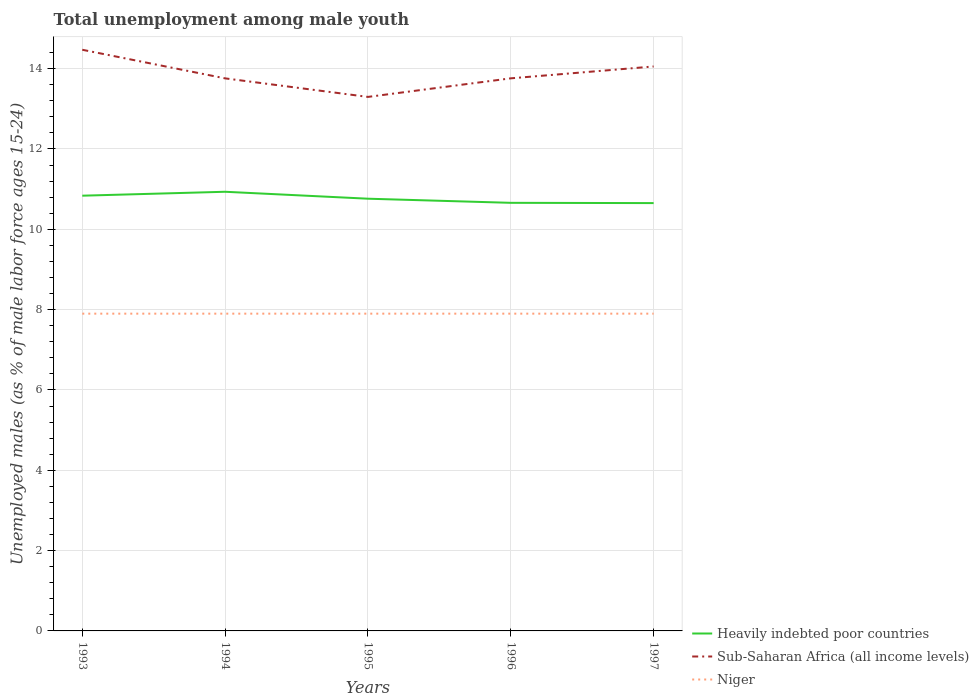How many different coloured lines are there?
Offer a very short reply. 3. Is the number of lines equal to the number of legend labels?
Make the answer very short. Yes. Across all years, what is the maximum percentage of unemployed males in in Niger?
Give a very brief answer. 7.9. What is the total percentage of unemployed males in in Heavily indebted poor countries in the graph?
Make the answer very short. 0.28. What is the difference between the highest and the second highest percentage of unemployed males in in Heavily indebted poor countries?
Ensure brevity in your answer.  0.28. What is the difference between the highest and the lowest percentage of unemployed males in in Sub-Saharan Africa (all income levels)?
Provide a short and direct response. 2. How many lines are there?
Ensure brevity in your answer.  3. How many years are there in the graph?
Your response must be concise. 5. Are the values on the major ticks of Y-axis written in scientific E-notation?
Give a very brief answer. No. Does the graph contain grids?
Provide a succinct answer. Yes. Where does the legend appear in the graph?
Give a very brief answer. Bottom right. How many legend labels are there?
Provide a succinct answer. 3. How are the legend labels stacked?
Your response must be concise. Vertical. What is the title of the graph?
Offer a very short reply. Total unemployment among male youth. Does "Barbados" appear as one of the legend labels in the graph?
Your answer should be compact. No. What is the label or title of the Y-axis?
Give a very brief answer. Unemployed males (as % of male labor force ages 15-24). What is the Unemployed males (as % of male labor force ages 15-24) of Heavily indebted poor countries in 1993?
Give a very brief answer. 10.84. What is the Unemployed males (as % of male labor force ages 15-24) of Sub-Saharan Africa (all income levels) in 1993?
Give a very brief answer. 14.47. What is the Unemployed males (as % of male labor force ages 15-24) in Niger in 1993?
Your answer should be compact. 7.9. What is the Unemployed males (as % of male labor force ages 15-24) in Heavily indebted poor countries in 1994?
Provide a succinct answer. 10.94. What is the Unemployed males (as % of male labor force ages 15-24) in Sub-Saharan Africa (all income levels) in 1994?
Provide a succinct answer. 13.76. What is the Unemployed males (as % of male labor force ages 15-24) in Niger in 1994?
Give a very brief answer. 7.9. What is the Unemployed males (as % of male labor force ages 15-24) of Heavily indebted poor countries in 1995?
Offer a very short reply. 10.76. What is the Unemployed males (as % of male labor force ages 15-24) in Sub-Saharan Africa (all income levels) in 1995?
Keep it short and to the point. 13.3. What is the Unemployed males (as % of male labor force ages 15-24) in Niger in 1995?
Ensure brevity in your answer.  7.9. What is the Unemployed males (as % of male labor force ages 15-24) of Heavily indebted poor countries in 1996?
Your answer should be very brief. 10.66. What is the Unemployed males (as % of male labor force ages 15-24) in Sub-Saharan Africa (all income levels) in 1996?
Your answer should be very brief. 13.76. What is the Unemployed males (as % of male labor force ages 15-24) of Niger in 1996?
Keep it short and to the point. 7.9. What is the Unemployed males (as % of male labor force ages 15-24) in Heavily indebted poor countries in 1997?
Offer a very short reply. 10.65. What is the Unemployed males (as % of male labor force ages 15-24) in Sub-Saharan Africa (all income levels) in 1997?
Your response must be concise. 14.06. What is the Unemployed males (as % of male labor force ages 15-24) of Niger in 1997?
Keep it short and to the point. 7.9. Across all years, what is the maximum Unemployed males (as % of male labor force ages 15-24) of Heavily indebted poor countries?
Make the answer very short. 10.94. Across all years, what is the maximum Unemployed males (as % of male labor force ages 15-24) of Sub-Saharan Africa (all income levels)?
Ensure brevity in your answer.  14.47. Across all years, what is the maximum Unemployed males (as % of male labor force ages 15-24) of Niger?
Your answer should be compact. 7.9. Across all years, what is the minimum Unemployed males (as % of male labor force ages 15-24) of Heavily indebted poor countries?
Ensure brevity in your answer.  10.65. Across all years, what is the minimum Unemployed males (as % of male labor force ages 15-24) in Sub-Saharan Africa (all income levels)?
Keep it short and to the point. 13.3. Across all years, what is the minimum Unemployed males (as % of male labor force ages 15-24) of Niger?
Offer a terse response. 7.9. What is the total Unemployed males (as % of male labor force ages 15-24) in Heavily indebted poor countries in the graph?
Provide a short and direct response. 53.85. What is the total Unemployed males (as % of male labor force ages 15-24) of Sub-Saharan Africa (all income levels) in the graph?
Offer a very short reply. 69.34. What is the total Unemployed males (as % of male labor force ages 15-24) of Niger in the graph?
Your answer should be compact. 39.5. What is the difference between the Unemployed males (as % of male labor force ages 15-24) in Heavily indebted poor countries in 1993 and that in 1994?
Offer a very short reply. -0.1. What is the difference between the Unemployed males (as % of male labor force ages 15-24) in Sub-Saharan Africa (all income levels) in 1993 and that in 1994?
Ensure brevity in your answer.  0.71. What is the difference between the Unemployed males (as % of male labor force ages 15-24) in Heavily indebted poor countries in 1993 and that in 1995?
Your response must be concise. 0.07. What is the difference between the Unemployed males (as % of male labor force ages 15-24) in Sub-Saharan Africa (all income levels) in 1993 and that in 1995?
Offer a terse response. 1.17. What is the difference between the Unemployed males (as % of male labor force ages 15-24) of Heavily indebted poor countries in 1993 and that in 1996?
Offer a terse response. 0.18. What is the difference between the Unemployed males (as % of male labor force ages 15-24) of Sub-Saharan Africa (all income levels) in 1993 and that in 1996?
Make the answer very short. 0.71. What is the difference between the Unemployed males (as % of male labor force ages 15-24) of Heavily indebted poor countries in 1993 and that in 1997?
Your answer should be very brief. 0.18. What is the difference between the Unemployed males (as % of male labor force ages 15-24) in Sub-Saharan Africa (all income levels) in 1993 and that in 1997?
Your answer should be very brief. 0.42. What is the difference between the Unemployed males (as % of male labor force ages 15-24) in Niger in 1993 and that in 1997?
Ensure brevity in your answer.  0. What is the difference between the Unemployed males (as % of male labor force ages 15-24) of Heavily indebted poor countries in 1994 and that in 1995?
Your answer should be very brief. 0.17. What is the difference between the Unemployed males (as % of male labor force ages 15-24) of Sub-Saharan Africa (all income levels) in 1994 and that in 1995?
Your response must be concise. 0.46. What is the difference between the Unemployed males (as % of male labor force ages 15-24) in Niger in 1994 and that in 1995?
Your answer should be compact. 0. What is the difference between the Unemployed males (as % of male labor force ages 15-24) of Heavily indebted poor countries in 1994 and that in 1996?
Offer a terse response. 0.28. What is the difference between the Unemployed males (as % of male labor force ages 15-24) of Sub-Saharan Africa (all income levels) in 1994 and that in 1996?
Offer a very short reply. -0. What is the difference between the Unemployed males (as % of male labor force ages 15-24) of Niger in 1994 and that in 1996?
Provide a succinct answer. 0. What is the difference between the Unemployed males (as % of male labor force ages 15-24) of Heavily indebted poor countries in 1994 and that in 1997?
Ensure brevity in your answer.  0.28. What is the difference between the Unemployed males (as % of male labor force ages 15-24) of Sub-Saharan Africa (all income levels) in 1994 and that in 1997?
Your response must be concise. -0.3. What is the difference between the Unemployed males (as % of male labor force ages 15-24) of Heavily indebted poor countries in 1995 and that in 1996?
Keep it short and to the point. 0.1. What is the difference between the Unemployed males (as % of male labor force ages 15-24) of Sub-Saharan Africa (all income levels) in 1995 and that in 1996?
Your answer should be very brief. -0.46. What is the difference between the Unemployed males (as % of male labor force ages 15-24) of Niger in 1995 and that in 1996?
Ensure brevity in your answer.  0. What is the difference between the Unemployed males (as % of male labor force ages 15-24) of Heavily indebted poor countries in 1995 and that in 1997?
Offer a terse response. 0.11. What is the difference between the Unemployed males (as % of male labor force ages 15-24) of Sub-Saharan Africa (all income levels) in 1995 and that in 1997?
Keep it short and to the point. -0.76. What is the difference between the Unemployed males (as % of male labor force ages 15-24) of Niger in 1995 and that in 1997?
Provide a succinct answer. 0. What is the difference between the Unemployed males (as % of male labor force ages 15-24) in Heavily indebted poor countries in 1996 and that in 1997?
Make the answer very short. 0.01. What is the difference between the Unemployed males (as % of male labor force ages 15-24) in Sub-Saharan Africa (all income levels) in 1996 and that in 1997?
Provide a short and direct response. -0.3. What is the difference between the Unemployed males (as % of male labor force ages 15-24) of Niger in 1996 and that in 1997?
Ensure brevity in your answer.  0. What is the difference between the Unemployed males (as % of male labor force ages 15-24) in Heavily indebted poor countries in 1993 and the Unemployed males (as % of male labor force ages 15-24) in Sub-Saharan Africa (all income levels) in 1994?
Give a very brief answer. -2.92. What is the difference between the Unemployed males (as % of male labor force ages 15-24) of Heavily indebted poor countries in 1993 and the Unemployed males (as % of male labor force ages 15-24) of Niger in 1994?
Offer a terse response. 2.94. What is the difference between the Unemployed males (as % of male labor force ages 15-24) of Sub-Saharan Africa (all income levels) in 1993 and the Unemployed males (as % of male labor force ages 15-24) of Niger in 1994?
Provide a short and direct response. 6.57. What is the difference between the Unemployed males (as % of male labor force ages 15-24) in Heavily indebted poor countries in 1993 and the Unemployed males (as % of male labor force ages 15-24) in Sub-Saharan Africa (all income levels) in 1995?
Your response must be concise. -2.46. What is the difference between the Unemployed males (as % of male labor force ages 15-24) in Heavily indebted poor countries in 1993 and the Unemployed males (as % of male labor force ages 15-24) in Niger in 1995?
Keep it short and to the point. 2.94. What is the difference between the Unemployed males (as % of male labor force ages 15-24) in Sub-Saharan Africa (all income levels) in 1993 and the Unemployed males (as % of male labor force ages 15-24) in Niger in 1995?
Provide a succinct answer. 6.57. What is the difference between the Unemployed males (as % of male labor force ages 15-24) of Heavily indebted poor countries in 1993 and the Unemployed males (as % of male labor force ages 15-24) of Sub-Saharan Africa (all income levels) in 1996?
Ensure brevity in your answer.  -2.92. What is the difference between the Unemployed males (as % of male labor force ages 15-24) of Heavily indebted poor countries in 1993 and the Unemployed males (as % of male labor force ages 15-24) of Niger in 1996?
Ensure brevity in your answer.  2.94. What is the difference between the Unemployed males (as % of male labor force ages 15-24) in Sub-Saharan Africa (all income levels) in 1993 and the Unemployed males (as % of male labor force ages 15-24) in Niger in 1996?
Keep it short and to the point. 6.57. What is the difference between the Unemployed males (as % of male labor force ages 15-24) in Heavily indebted poor countries in 1993 and the Unemployed males (as % of male labor force ages 15-24) in Sub-Saharan Africa (all income levels) in 1997?
Offer a terse response. -3.22. What is the difference between the Unemployed males (as % of male labor force ages 15-24) of Heavily indebted poor countries in 1993 and the Unemployed males (as % of male labor force ages 15-24) of Niger in 1997?
Your answer should be very brief. 2.94. What is the difference between the Unemployed males (as % of male labor force ages 15-24) of Sub-Saharan Africa (all income levels) in 1993 and the Unemployed males (as % of male labor force ages 15-24) of Niger in 1997?
Provide a succinct answer. 6.57. What is the difference between the Unemployed males (as % of male labor force ages 15-24) of Heavily indebted poor countries in 1994 and the Unemployed males (as % of male labor force ages 15-24) of Sub-Saharan Africa (all income levels) in 1995?
Your answer should be very brief. -2.36. What is the difference between the Unemployed males (as % of male labor force ages 15-24) in Heavily indebted poor countries in 1994 and the Unemployed males (as % of male labor force ages 15-24) in Niger in 1995?
Provide a short and direct response. 3.04. What is the difference between the Unemployed males (as % of male labor force ages 15-24) of Sub-Saharan Africa (all income levels) in 1994 and the Unemployed males (as % of male labor force ages 15-24) of Niger in 1995?
Offer a very short reply. 5.86. What is the difference between the Unemployed males (as % of male labor force ages 15-24) of Heavily indebted poor countries in 1994 and the Unemployed males (as % of male labor force ages 15-24) of Sub-Saharan Africa (all income levels) in 1996?
Offer a very short reply. -2.82. What is the difference between the Unemployed males (as % of male labor force ages 15-24) in Heavily indebted poor countries in 1994 and the Unemployed males (as % of male labor force ages 15-24) in Niger in 1996?
Make the answer very short. 3.04. What is the difference between the Unemployed males (as % of male labor force ages 15-24) in Sub-Saharan Africa (all income levels) in 1994 and the Unemployed males (as % of male labor force ages 15-24) in Niger in 1996?
Make the answer very short. 5.86. What is the difference between the Unemployed males (as % of male labor force ages 15-24) in Heavily indebted poor countries in 1994 and the Unemployed males (as % of male labor force ages 15-24) in Sub-Saharan Africa (all income levels) in 1997?
Keep it short and to the point. -3.12. What is the difference between the Unemployed males (as % of male labor force ages 15-24) in Heavily indebted poor countries in 1994 and the Unemployed males (as % of male labor force ages 15-24) in Niger in 1997?
Offer a terse response. 3.04. What is the difference between the Unemployed males (as % of male labor force ages 15-24) in Sub-Saharan Africa (all income levels) in 1994 and the Unemployed males (as % of male labor force ages 15-24) in Niger in 1997?
Give a very brief answer. 5.86. What is the difference between the Unemployed males (as % of male labor force ages 15-24) in Heavily indebted poor countries in 1995 and the Unemployed males (as % of male labor force ages 15-24) in Sub-Saharan Africa (all income levels) in 1996?
Your answer should be compact. -3. What is the difference between the Unemployed males (as % of male labor force ages 15-24) in Heavily indebted poor countries in 1995 and the Unemployed males (as % of male labor force ages 15-24) in Niger in 1996?
Provide a short and direct response. 2.86. What is the difference between the Unemployed males (as % of male labor force ages 15-24) of Sub-Saharan Africa (all income levels) in 1995 and the Unemployed males (as % of male labor force ages 15-24) of Niger in 1996?
Your answer should be compact. 5.4. What is the difference between the Unemployed males (as % of male labor force ages 15-24) in Heavily indebted poor countries in 1995 and the Unemployed males (as % of male labor force ages 15-24) in Sub-Saharan Africa (all income levels) in 1997?
Give a very brief answer. -3.29. What is the difference between the Unemployed males (as % of male labor force ages 15-24) of Heavily indebted poor countries in 1995 and the Unemployed males (as % of male labor force ages 15-24) of Niger in 1997?
Offer a very short reply. 2.86. What is the difference between the Unemployed males (as % of male labor force ages 15-24) in Sub-Saharan Africa (all income levels) in 1995 and the Unemployed males (as % of male labor force ages 15-24) in Niger in 1997?
Provide a short and direct response. 5.4. What is the difference between the Unemployed males (as % of male labor force ages 15-24) in Heavily indebted poor countries in 1996 and the Unemployed males (as % of male labor force ages 15-24) in Sub-Saharan Africa (all income levels) in 1997?
Keep it short and to the point. -3.4. What is the difference between the Unemployed males (as % of male labor force ages 15-24) of Heavily indebted poor countries in 1996 and the Unemployed males (as % of male labor force ages 15-24) of Niger in 1997?
Provide a succinct answer. 2.76. What is the difference between the Unemployed males (as % of male labor force ages 15-24) of Sub-Saharan Africa (all income levels) in 1996 and the Unemployed males (as % of male labor force ages 15-24) of Niger in 1997?
Your answer should be compact. 5.86. What is the average Unemployed males (as % of male labor force ages 15-24) in Heavily indebted poor countries per year?
Keep it short and to the point. 10.77. What is the average Unemployed males (as % of male labor force ages 15-24) in Sub-Saharan Africa (all income levels) per year?
Offer a very short reply. 13.87. In the year 1993, what is the difference between the Unemployed males (as % of male labor force ages 15-24) in Heavily indebted poor countries and Unemployed males (as % of male labor force ages 15-24) in Sub-Saharan Africa (all income levels)?
Give a very brief answer. -3.63. In the year 1993, what is the difference between the Unemployed males (as % of male labor force ages 15-24) of Heavily indebted poor countries and Unemployed males (as % of male labor force ages 15-24) of Niger?
Your response must be concise. 2.94. In the year 1993, what is the difference between the Unemployed males (as % of male labor force ages 15-24) in Sub-Saharan Africa (all income levels) and Unemployed males (as % of male labor force ages 15-24) in Niger?
Your answer should be very brief. 6.57. In the year 1994, what is the difference between the Unemployed males (as % of male labor force ages 15-24) in Heavily indebted poor countries and Unemployed males (as % of male labor force ages 15-24) in Sub-Saharan Africa (all income levels)?
Keep it short and to the point. -2.82. In the year 1994, what is the difference between the Unemployed males (as % of male labor force ages 15-24) of Heavily indebted poor countries and Unemployed males (as % of male labor force ages 15-24) of Niger?
Your answer should be compact. 3.04. In the year 1994, what is the difference between the Unemployed males (as % of male labor force ages 15-24) of Sub-Saharan Africa (all income levels) and Unemployed males (as % of male labor force ages 15-24) of Niger?
Provide a short and direct response. 5.86. In the year 1995, what is the difference between the Unemployed males (as % of male labor force ages 15-24) in Heavily indebted poor countries and Unemployed males (as % of male labor force ages 15-24) in Sub-Saharan Africa (all income levels)?
Your response must be concise. -2.53. In the year 1995, what is the difference between the Unemployed males (as % of male labor force ages 15-24) in Heavily indebted poor countries and Unemployed males (as % of male labor force ages 15-24) in Niger?
Your answer should be very brief. 2.86. In the year 1995, what is the difference between the Unemployed males (as % of male labor force ages 15-24) in Sub-Saharan Africa (all income levels) and Unemployed males (as % of male labor force ages 15-24) in Niger?
Your answer should be compact. 5.4. In the year 1996, what is the difference between the Unemployed males (as % of male labor force ages 15-24) in Heavily indebted poor countries and Unemployed males (as % of male labor force ages 15-24) in Sub-Saharan Africa (all income levels)?
Give a very brief answer. -3.1. In the year 1996, what is the difference between the Unemployed males (as % of male labor force ages 15-24) in Heavily indebted poor countries and Unemployed males (as % of male labor force ages 15-24) in Niger?
Give a very brief answer. 2.76. In the year 1996, what is the difference between the Unemployed males (as % of male labor force ages 15-24) in Sub-Saharan Africa (all income levels) and Unemployed males (as % of male labor force ages 15-24) in Niger?
Provide a short and direct response. 5.86. In the year 1997, what is the difference between the Unemployed males (as % of male labor force ages 15-24) in Heavily indebted poor countries and Unemployed males (as % of male labor force ages 15-24) in Sub-Saharan Africa (all income levels)?
Your response must be concise. -3.4. In the year 1997, what is the difference between the Unemployed males (as % of male labor force ages 15-24) in Heavily indebted poor countries and Unemployed males (as % of male labor force ages 15-24) in Niger?
Make the answer very short. 2.75. In the year 1997, what is the difference between the Unemployed males (as % of male labor force ages 15-24) of Sub-Saharan Africa (all income levels) and Unemployed males (as % of male labor force ages 15-24) of Niger?
Make the answer very short. 6.16. What is the ratio of the Unemployed males (as % of male labor force ages 15-24) of Heavily indebted poor countries in 1993 to that in 1994?
Your response must be concise. 0.99. What is the ratio of the Unemployed males (as % of male labor force ages 15-24) of Sub-Saharan Africa (all income levels) in 1993 to that in 1994?
Ensure brevity in your answer.  1.05. What is the ratio of the Unemployed males (as % of male labor force ages 15-24) in Niger in 1993 to that in 1994?
Make the answer very short. 1. What is the ratio of the Unemployed males (as % of male labor force ages 15-24) in Sub-Saharan Africa (all income levels) in 1993 to that in 1995?
Offer a terse response. 1.09. What is the ratio of the Unemployed males (as % of male labor force ages 15-24) in Heavily indebted poor countries in 1993 to that in 1996?
Ensure brevity in your answer.  1.02. What is the ratio of the Unemployed males (as % of male labor force ages 15-24) of Sub-Saharan Africa (all income levels) in 1993 to that in 1996?
Provide a short and direct response. 1.05. What is the ratio of the Unemployed males (as % of male labor force ages 15-24) in Niger in 1993 to that in 1996?
Provide a succinct answer. 1. What is the ratio of the Unemployed males (as % of male labor force ages 15-24) of Heavily indebted poor countries in 1993 to that in 1997?
Keep it short and to the point. 1.02. What is the ratio of the Unemployed males (as % of male labor force ages 15-24) of Sub-Saharan Africa (all income levels) in 1993 to that in 1997?
Your answer should be compact. 1.03. What is the ratio of the Unemployed males (as % of male labor force ages 15-24) in Sub-Saharan Africa (all income levels) in 1994 to that in 1995?
Your answer should be very brief. 1.03. What is the ratio of the Unemployed males (as % of male labor force ages 15-24) in Niger in 1994 to that in 1995?
Your answer should be very brief. 1. What is the ratio of the Unemployed males (as % of male labor force ages 15-24) of Heavily indebted poor countries in 1994 to that in 1996?
Give a very brief answer. 1.03. What is the ratio of the Unemployed males (as % of male labor force ages 15-24) in Sub-Saharan Africa (all income levels) in 1994 to that in 1996?
Ensure brevity in your answer.  1. What is the ratio of the Unemployed males (as % of male labor force ages 15-24) of Heavily indebted poor countries in 1994 to that in 1997?
Give a very brief answer. 1.03. What is the ratio of the Unemployed males (as % of male labor force ages 15-24) in Sub-Saharan Africa (all income levels) in 1994 to that in 1997?
Ensure brevity in your answer.  0.98. What is the ratio of the Unemployed males (as % of male labor force ages 15-24) of Niger in 1994 to that in 1997?
Your answer should be very brief. 1. What is the ratio of the Unemployed males (as % of male labor force ages 15-24) of Heavily indebted poor countries in 1995 to that in 1996?
Provide a short and direct response. 1.01. What is the ratio of the Unemployed males (as % of male labor force ages 15-24) of Sub-Saharan Africa (all income levels) in 1995 to that in 1996?
Ensure brevity in your answer.  0.97. What is the ratio of the Unemployed males (as % of male labor force ages 15-24) of Heavily indebted poor countries in 1995 to that in 1997?
Provide a short and direct response. 1.01. What is the ratio of the Unemployed males (as % of male labor force ages 15-24) in Sub-Saharan Africa (all income levels) in 1995 to that in 1997?
Your response must be concise. 0.95. What is the ratio of the Unemployed males (as % of male labor force ages 15-24) of Niger in 1995 to that in 1997?
Offer a terse response. 1. What is the ratio of the Unemployed males (as % of male labor force ages 15-24) of Sub-Saharan Africa (all income levels) in 1996 to that in 1997?
Your response must be concise. 0.98. What is the difference between the highest and the second highest Unemployed males (as % of male labor force ages 15-24) of Heavily indebted poor countries?
Make the answer very short. 0.1. What is the difference between the highest and the second highest Unemployed males (as % of male labor force ages 15-24) in Sub-Saharan Africa (all income levels)?
Provide a short and direct response. 0.42. What is the difference between the highest and the lowest Unemployed males (as % of male labor force ages 15-24) in Heavily indebted poor countries?
Make the answer very short. 0.28. What is the difference between the highest and the lowest Unemployed males (as % of male labor force ages 15-24) of Sub-Saharan Africa (all income levels)?
Provide a short and direct response. 1.17. What is the difference between the highest and the lowest Unemployed males (as % of male labor force ages 15-24) of Niger?
Keep it short and to the point. 0. 